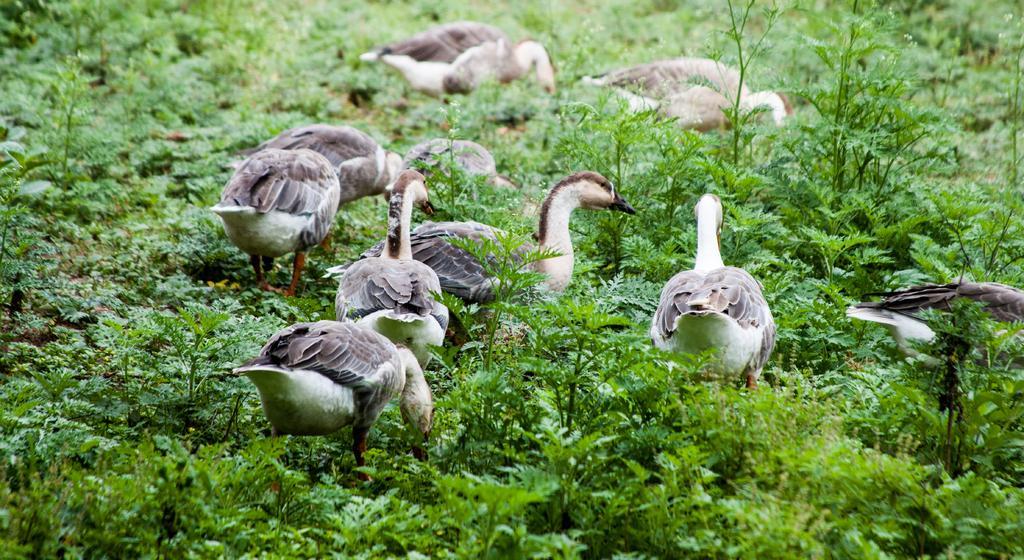Please provide a concise description of this image. In this image I can see few plants which are green in color on the ground and I can see few birds which are cream, black, white and black in color. 